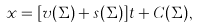Convert formula to latex. <formula><loc_0><loc_0><loc_500><loc_500>x = [ v ( \Sigma ) + s ( \Sigma ) ] t + C ( \Sigma ) ,</formula> 